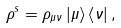<formula> <loc_0><loc_0><loc_500><loc_500>\rho ^ { s } = \rho _ { \mu \nu } \left | \mu \right > \left < \nu \right | ,</formula> 